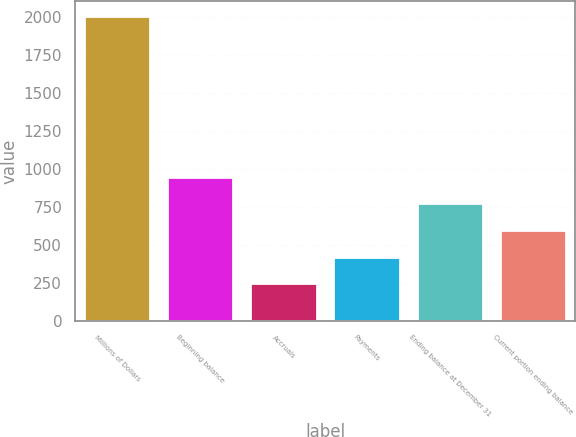Convert chart to OTSL. <chart><loc_0><loc_0><loc_500><loc_500><bar_chart><fcel>Millions of Dollars<fcel>Beginning balance<fcel>Accruals<fcel>Payments<fcel>Ending balance at December 31<fcel>Current portion ending balance<nl><fcel>2005<fcel>950.2<fcel>247<fcel>422.8<fcel>774.4<fcel>598.6<nl></chart> 